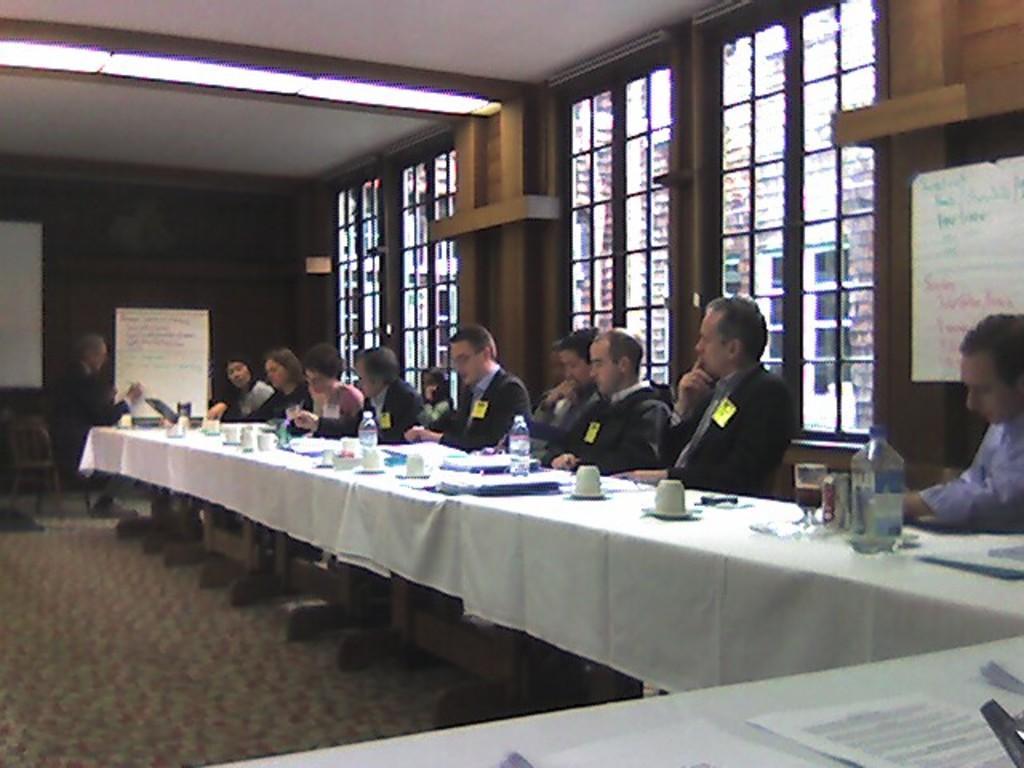In one or two sentences, can you explain what this image depicts? In this image I can see few persons sitting on the chairs. I can see few cups, bottles and glasses on the table. I can see two notice boards. In the background I can see windows. At the top I can see lights hanged to the ceiling. 